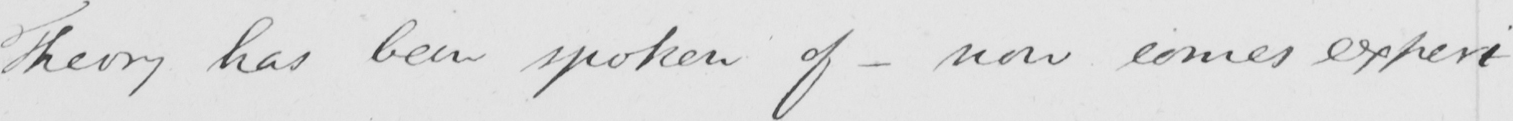Can you read and transcribe this handwriting? Theory has been spoken of  _ now comes experi- 